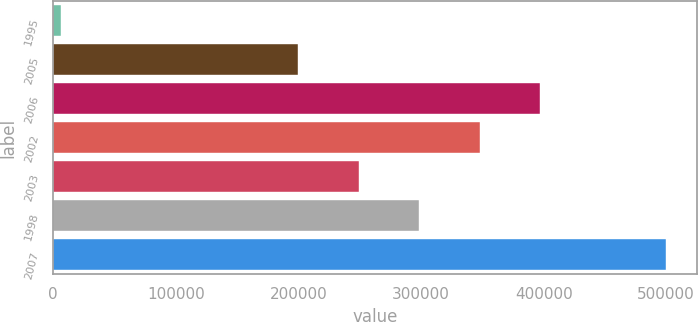Convert chart to OTSL. <chart><loc_0><loc_0><loc_500><loc_500><bar_chart><fcel>1995<fcel>2005<fcel>2006<fcel>2002<fcel>2003<fcel>1998<fcel>2007<nl><fcel>6421<fcel>200000<fcel>397432<fcel>348074<fcel>249358<fcel>298716<fcel>500000<nl></chart> 